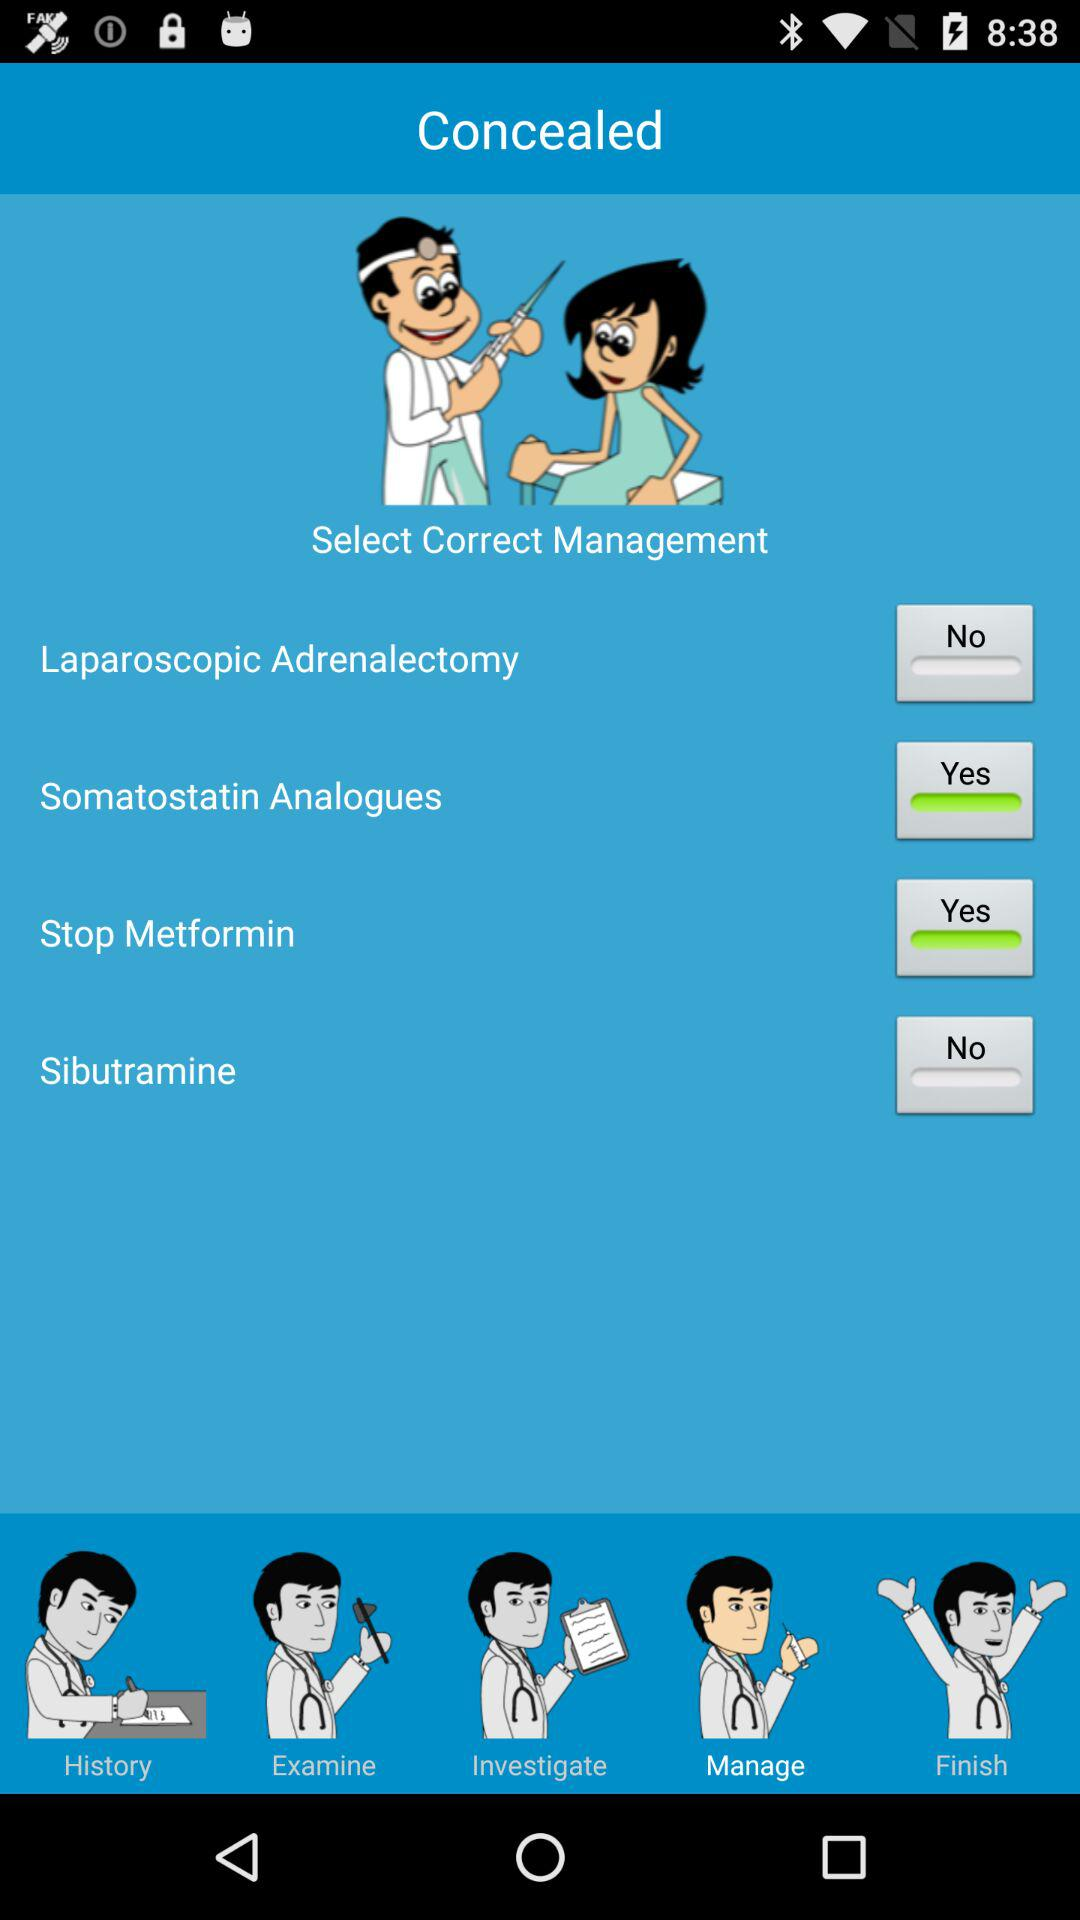Is "Sibutramine" on or off?
Answer the question using a single word or phrase. It is "off". 